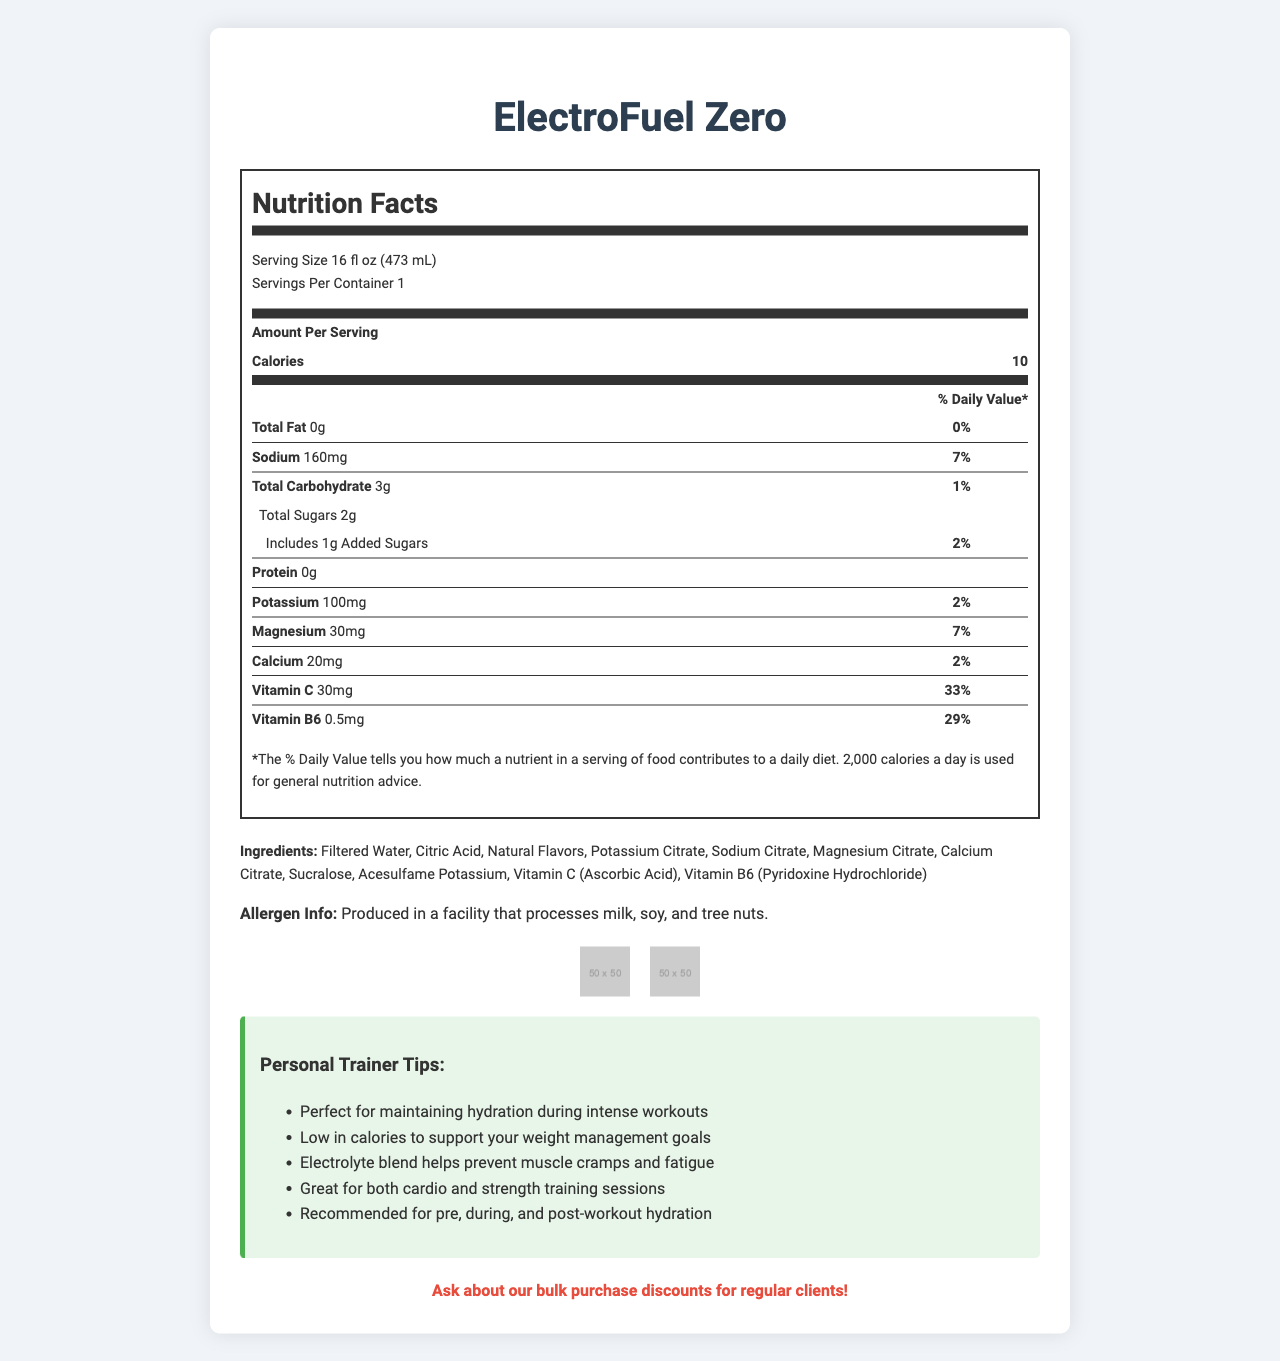what is the serving size of ElectroFuel Zero? The serving size is listed at the top of the Nutrition Facts section as "Serving Size 16 fl oz (473 mL)".
Answer: 16 fl oz (473 mL) how many calories are in one serving? The calories per serving are shown in the Amount Per Serving section as "Calories 10".
Answer: 10 what is the amount of sodium in one serving? The sodium content is listed under the nutritional values as "Sodium 160mg".
Answer: 160mg what percentage of the daily value of Vitamin C does ElectroFuel Zero provide? The daily value percentage for Vitamin C is shown as "Vitamin C 30mg 33%".
Answer: 33% list the ingredients of ElectroFuel Zero. The ingredients list is found in the Ingredients section: "Filtered Water, Citric Acid, Natural Flavors, Potassium Citrate, Sodium Citrate, Magnesium Citrate, Calcium Citrate, Sucralose, Acesulfame Potassium, Vitamin C (Ascorbic Acid), Vitamin B6 (Pyridoxine Hydrochloride)".
Answer: Filtered Water, Citric Acid, Natural Flavors, Potassium Citrate, Sodium Citrate, Magnesium Citrate, Calcium Citrate, Sucralose, Acesulfame Potassium, Vitamin C (Ascorbic Acid), Vitamin B6 (Pyridoxine Hydrochloride) what is the amount of potassium per serving? The amount of potassium per serving is shown in the nutritional values section as "Potassium 100mg".
Answer: 100mg where is ElectroFuel Zero produced? The document specifies that it is produced in a facility that processes milk, soy, and tree nuts, but it does not specify the location.
Answer: Cannot be determined which certification does ElectroFuel Zero have? A. USDA Organic B. Non-GMO Project Verified C. Gluten-Free D. Kosher The document lists "Non-GMO Project Verified" as one of the certifications for the product.
Answer: B. Non-GMO Project Verified what is the main purpose of ElectroFuel Zero according to the personal trainer tips? One of the personal trainer tips mentions that the product is perfect for maintaining hydration during intense workouts.
Answer: Hydration during intense workouts what percentage of your daily value of magnesium is in ElectroFuel Zero? A. 2% B. 7% C. 10% D. 29% The document shows that the daily value percentage for magnesium is 7%.
Answer: B. 7% does ElectroFuel Zero contain any protein? The nutritional information lists "Protein 0g", indicating that it does not contain any protein.
Answer: No should you shake ElectroFuel Zero before use? The additional information section advises to "Shake well before use".
Answer: Yes summarize the key nutritional benefits of ElectroFuel Zero. The explanation covers all the essential nutritional benefits mentioned in the document, including the low-calorie content and the presence of electrolytes and vitamins while also mentioning the product's certifications.
Answer: ElectroFuel Zero is a low-calorie sports drink with only 10 calories per serving. It is fortified with essential electrolytes including sodium, potassium, magnesium, and calcium to help prevent muscle cramps and fatigue. It also contains vitamins C and B6. The drink is non-GMO and vegan, making it especially suitable for a wide range of dietary preferences. how many added sugars are in ElectroFuel Zero? The nutritional values show that there are 1g of added sugars per serving.
Answer: 1g is ElectroFuel Zero vegan? The certifications section lists "Vegan" as one of the certifications for the product.
Answer: Yes 